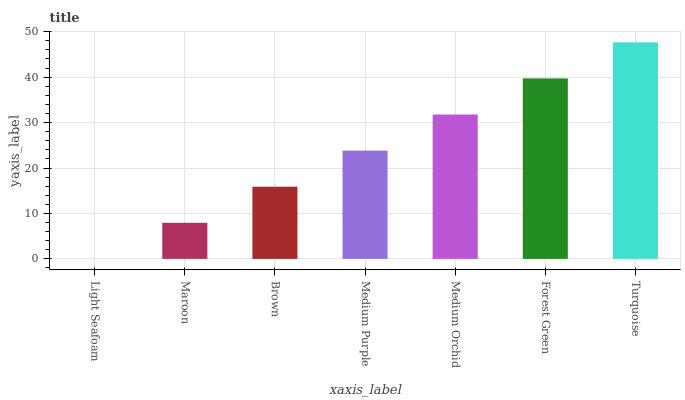Is Light Seafoam the minimum?
Answer yes or no. Yes. Is Turquoise the maximum?
Answer yes or no. Yes. Is Maroon the minimum?
Answer yes or no. No. Is Maroon the maximum?
Answer yes or no. No. Is Maroon greater than Light Seafoam?
Answer yes or no. Yes. Is Light Seafoam less than Maroon?
Answer yes or no. Yes. Is Light Seafoam greater than Maroon?
Answer yes or no. No. Is Maroon less than Light Seafoam?
Answer yes or no. No. Is Medium Purple the high median?
Answer yes or no. Yes. Is Medium Purple the low median?
Answer yes or no. Yes. Is Medium Orchid the high median?
Answer yes or no. No. Is Forest Green the low median?
Answer yes or no. No. 